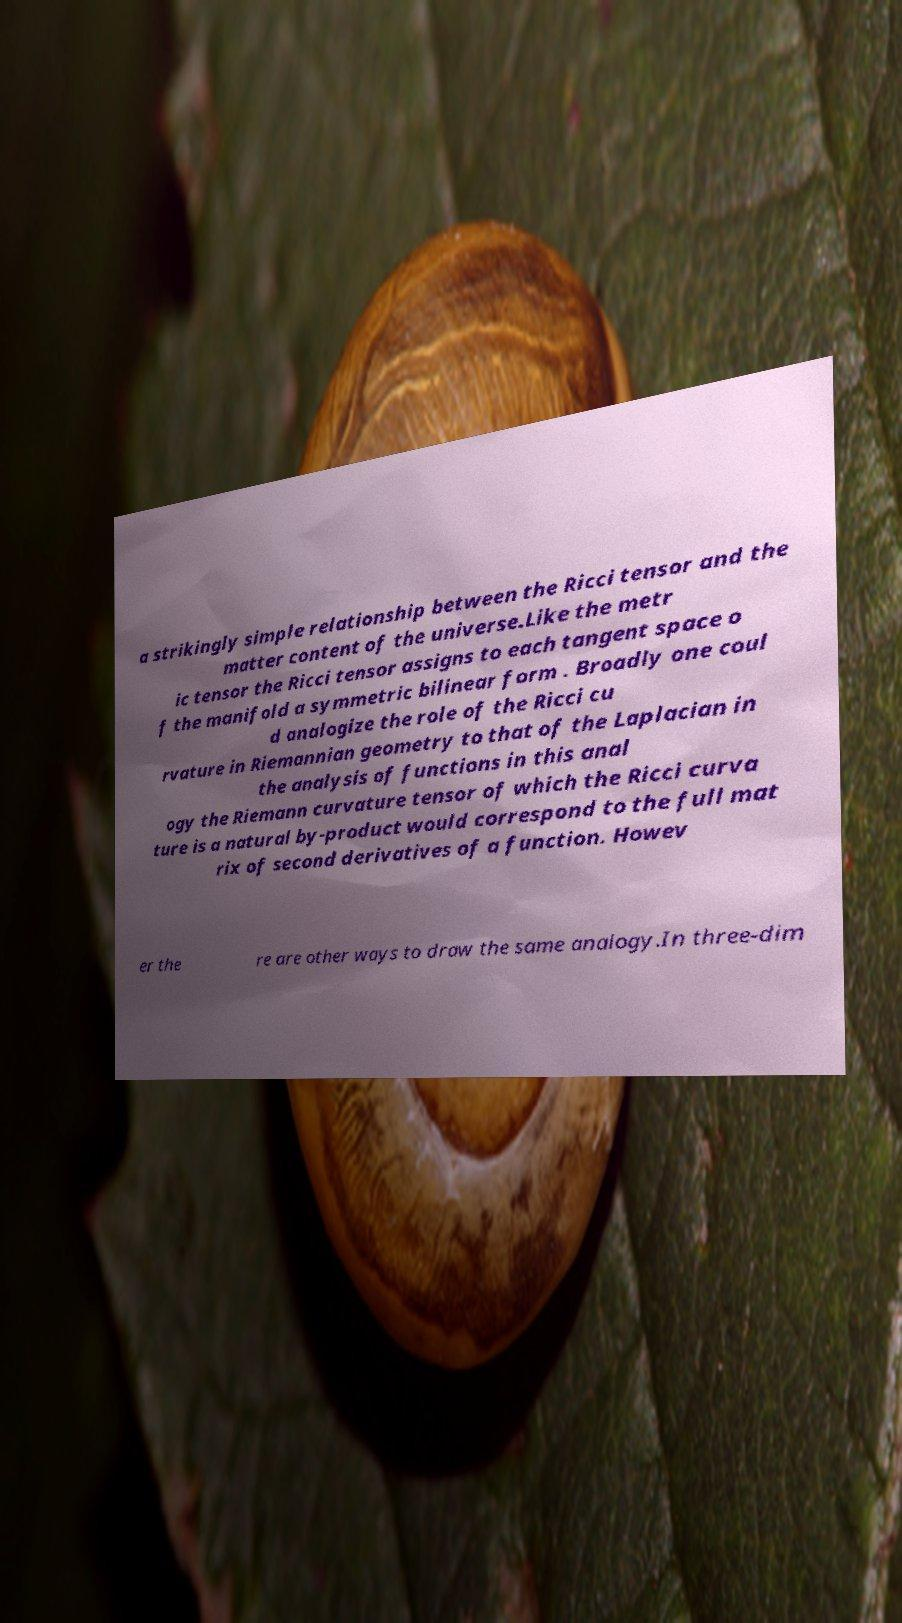Please identify and transcribe the text found in this image. a strikingly simple relationship between the Ricci tensor and the matter content of the universe.Like the metr ic tensor the Ricci tensor assigns to each tangent space o f the manifold a symmetric bilinear form . Broadly one coul d analogize the role of the Ricci cu rvature in Riemannian geometry to that of the Laplacian in the analysis of functions in this anal ogy the Riemann curvature tensor of which the Ricci curva ture is a natural by-product would correspond to the full mat rix of second derivatives of a function. Howev er the re are other ways to draw the same analogy.In three-dim 